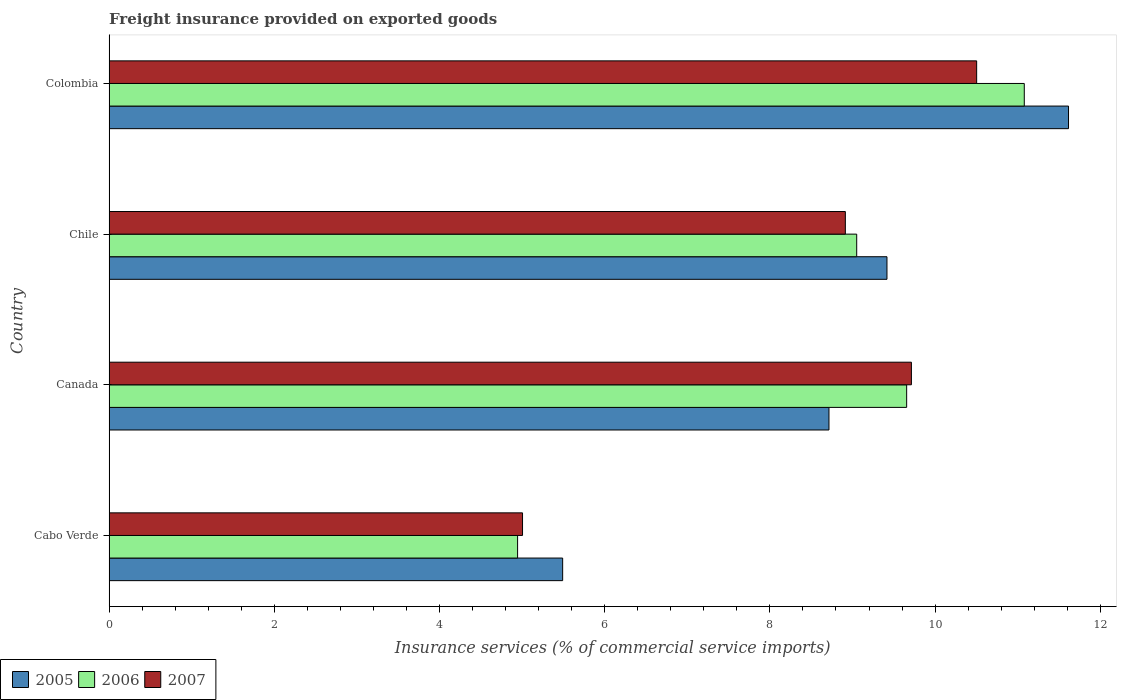How many different coloured bars are there?
Offer a very short reply. 3. Are the number of bars per tick equal to the number of legend labels?
Ensure brevity in your answer.  Yes. Are the number of bars on each tick of the Y-axis equal?
Offer a very short reply. Yes. How many bars are there on the 1st tick from the top?
Offer a very short reply. 3. What is the freight insurance provided on exported goods in 2006 in Cabo Verde?
Make the answer very short. 4.95. Across all countries, what is the maximum freight insurance provided on exported goods in 2006?
Your answer should be very brief. 11.08. Across all countries, what is the minimum freight insurance provided on exported goods in 2005?
Keep it short and to the point. 5.49. In which country was the freight insurance provided on exported goods in 2006 minimum?
Your answer should be compact. Cabo Verde. What is the total freight insurance provided on exported goods in 2005 in the graph?
Provide a succinct answer. 35.24. What is the difference between the freight insurance provided on exported goods in 2007 in Canada and that in Chile?
Your response must be concise. 0.8. What is the difference between the freight insurance provided on exported goods in 2005 in Canada and the freight insurance provided on exported goods in 2006 in Chile?
Ensure brevity in your answer.  -0.34. What is the average freight insurance provided on exported goods in 2005 per country?
Keep it short and to the point. 8.81. What is the difference between the freight insurance provided on exported goods in 2007 and freight insurance provided on exported goods in 2005 in Canada?
Offer a terse response. 1. What is the ratio of the freight insurance provided on exported goods in 2006 in Cabo Verde to that in Canada?
Offer a very short reply. 0.51. Is the freight insurance provided on exported goods in 2006 in Canada less than that in Colombia?
Your answer should be compact. Yes. What is the difference between the highest and the second highest freight insurance provided on exported goods in 2006?
Provide a short and direct response. 1.42. What is the difference between the highest and the lowest freight insurance provided on exported goods in 2005?
Your answer should be compact. 6.12. Is the sum of the freight insurance provided on exported goods in 2006 in Cabo Verde and Colombia greater than the maximum freight insurance provided on exported goods in 2007 across all countries?
Keep it short and to the point. Yes. What does the 1st bar from the top in Chile represents?
Provide a short and direct response. 2007. What does the 3rd bar from the bottom in Canada represents?
Make the answer very short. 2007. Is it the case that in every country, the sum of the freight insurance provided on exported goods in 2007 and freight insurance provided on exported goods in 2005 is greater than the freight insurance provided on exported goods in 2006?
Your response must be concise. Yes. Are the values on the major ticks of X-axis written in scientific E-notation?
Make the answer very short. No. Does the graph contain any zero values?
Give a very brief answer. No. Does the graph contain grids?
Your response must be concise. No. Where does the legend appear in the graph?
Provide a succinct answer. Bottom left. How many legend labels are there?
Ensure brevity in your answer.  3. How are the legend labels stacked?
Provide a succinct answer. Horizontal. What is the title of the graph?
Provide a short and direct response. Freight insurance provided on exported goods. Does "2015" appear as one of the legend labels in the graph?
Provide a short and direct response. No. What is the label or title of the X-axis?
Provide a short and direct response. Insurance services (% of commercial service imports). What is the Insurance services (% of commercial service imports) in 2005 in Cabo Verde?
Your answer should be very brief. 5.49. What is the Insurance services (% of commercial service imports) in 2006 in Cabo Verde?
Your response must be concise. 4.95. What is the Insurance services (% of commercial service imports) in 2007 in Cabo Verde?
Provide a short and direct response. 5.01. What is the Insurance services (% of commercial service imports) of 2005 in Canada?
Provide a short and direct response. 8.72. What is the Insurance services (% of commercial service imports) of 2006 in Canada?
Ensure brevity in your answer.  9.66. What is the Insurance services (% of commercial service imports) of 2007 in Canada?
Keep it short and to the point. 9.71. What is the Insurance services (% of commercial service imports) in 2005 in Chile?
Your answer should be compact. 9.42. What is the Insurance services (% of commercial service imports) of 2006 in Chile?
Your answer should be very brief. 9.05. What is the Insurance services (% of commercial service imports) of 2007 in Chile?
Provide a succinct answer. 8.91. What is the Insurance services (% of commercial service imports) in 2005 in Colombia?
Ensure brevity in your answer.  11.62. What is the Insurance services (% of commercial service imports) in 2006 in Colombia?
Provide a succinct answer. 11.08. What is the Insurance services (% of commercial service imports) in 2007 in Colombia?
Your answer should be compact. 10.5. Across all countries, what is the maximum Insurance services (% of commercial service imports) in 2005?
Give a very brief answer. 11.62. Across all countries, what is the maximum Insurance services (% of commercial service imports) of 2006?
Provide a succinct answer. 11.08. Across all countries, what is the maximum Insurance services (% of commercial service imports) in 2007?
Keep it short and to the point. 10.5. Across all countries, what is the minimum Insurance services (% of commercial service imports) in 2005?
Your answer should be very brief. 5.49. Across all countries, what is the minimum Insurance services (% of commercial service imports) in 2006?
Ensure brevity in your answer.  4.95. Across all countries, what is the minimum Insurance services (% of commercial service imports) of 2007?
Your answer should be compact. 5.01. What is the total Insurance services (% of commercial service imports) of 2005 in the graph?
Give a very brief answer. 35.24. What is the total Insurance services (% of commercial service imports) of 2006 in the graph?
Your response must be concise. 34.73. What is the total Insurance services (% of commercial service imports) in 2007 in the graph?
Provide a succinct answer. 34.14. What is the difference between the Insurance services (% of commercial service imports) of 2005 in Cabo Verde and that in Canada?
Offer a very short reply. -3.22. What is the difference between the Insurance services (% of commercial service imports) of 2006 in Cabo Verde and that in Canada?
Your answer should be very brief. -4.71. What is the difference between the Insurance services (% of commercial service imports) in 2007 in Cabo Verde and that in Canada?
Provide a succinct answer. -4.71. What is the difference between the Insurance services (% of commercial service imports) of 2005 in Cabo Verde and that in Chile?
Provide a succinct answer. -3.93. What is the difference between the Insurance services (% of commercial service imports) of 2006 in Cabo Verde and that in Chile?
Provide a short and direct response. -4.11. What is the difference between the Insurance services (% of commercial service imports) in 2007 in Cabo Verde and that in Chile?
Ensure brevity in your answer.  -3.91. What is the difference between the Insurance services (% of commercial service imports) of 2005 in Cabo Verde and that in Colombia?
Give a very brief answer. -6.12. What is the difference between the Insurance services (% of commercial service imports) in 2006 in Cabo Verde and that in Colombia?
Provide a succinct answer. -6.13. What is the difference between the Insurance services (% of commercial service imports) in 2007 in Cabo Verde and that in Colombia?
Your response must be concise. -5.5. What is the difference between the Insurance services (% of commercial service imports) of 2005 in Canada and that in Chile?
Offer a terse response. -0.7. What is the difference between the Insurance services (% of commercial service imports) of 2006 in Canada and that in Chile?
Provide a short and direct response. 0.6. What is the difference between the Insurance services (% of commercial service imports) of 2007 in Canada and that in Chile?
Provide a short and direct response. 0.8. What is the difference between the Insurance services (% of commercial service imports) of 2005 in Canada and that in Colombia?
Keep it short and to the point. -2.9. What is the difference between the Insurance services (% of commercial service imports) in 2006 in Canada and that in Colombia?
Your answer should be very brief. -1.42. What is the difference between the Insurance services (% of commercial service imports) of 2007 in Canada and that in Colombia?
Give a very brief answer. -0.79. What is the difference between the Insurance services (% of commercial service imports) of 2005 in Chile and that in Colombia?
Offer a terse response. -2.2. What is the difference between the Insurance services (% of commercial service imports) of 2006 in Chile and that in Colombia?
Your answer should be very brief. -2.03. What is the difference between the Insurance services (% of commercial service imports) in 2007 in Chile and that in Colombia?
Give a very brief answer. -1.59. What is the difference between the Insurance services (% of commercial service imports) of 2005 in Cabo Verde and the Insurance services (% of commercial service imports) of 2006 in Canada?
Your answer should be compact. -4.16. What is the difference between the Insurance services (% of commercial service imports) in 2005 in Cabo Verde and the Insurance services (% of commercial service imports) in 2007 in Canada?
Offer a very short reply. -4.22. What is the difference between the Insurance services (% of commercial service imports) of 2006 in Cabo Verde and the Insurance services (% of commercial service imports) of 2007 in Canada?
Provide a short and direct response. -4.77. What is the difference between the Insurance services (% of commercial service imports) of 2005 in Cabo Verde and the Insurance services (% of commercial service imports) of 2006 in Chile?
Provide a short and direct response. -3.56. What is the difference between the Insurance services (% of commercial service imports) in 2005 in Cabo Verde and the Insurance services (% of commercial service imports) in 2007 in Chile?
Provide a succinct answer. -3.42. What is the difference between the Insurance services (% of commercial service imports) of 2006 in Cabo Verde and the Insurance services (% of commercial service imports) of 2007 in Chile?
Your response must be concise. -3.97. What is the difference between the Insurance services (% of commercial service imports) in 2005 in Cabo Verde and the Insurance services (% of commercial service imports) in 2006 in Colombia?
Offer a very short reply. -5.59. What is the difference between the Insurance services (% of commercial service imports) of 2005 in Cabo Verde and the Insurance services (% of commercial service imports) of 2007 in Colombia?
Give a very brief answer. -5.01. What is the difference between the Insurance services (% of commercial service imports) in 2006 in Cabo Verde and the Insurance services (% of commercial service imports) in 2007 in Colombia?
Your answer should be compact. -5.56. What is the difference between the Insurance services (% of commercial service imports) of 2005 in Canada and the Insurance services (% of commercial service imports) of 2006 in Chile?
Your answer should be very brief. -0.34. What is the difference between the Insurance services (% of commercial service imports) in 2005 in Canada and the Insurance services (% of commercial service imports) in 2007 in Chile?
Make the answer very short. -0.2. What is the difference between the Insurance services (% of commercial service imports) in 2006 in Canada and the Insurance services (% of commercial service imports) in 2007 in Chile?
Offer a terse response. 0.74. What is the difference between the Insurance services (% of commercial service imports) of 2005 in Canada and the Insurance services (% of commercial service imports) of 2006 in Colombia?
Ensure brevity in your answer.  -2.36. What is the difference between the Insurance services (% of commercial service imports) of 2005 in Canada and the Insurance services (% of commercial service imports) of 2007 in Colombia?
Provide a succinct answer. -1.79. What is the difference between the Insurance services (% of commercial service imports) of 2006 in Canada and the Insurance services (% of commercial service imports) of 2007 in Colombia?
Offer a very short reply. -0.85. What is the difference between the Insurance services (% of commercial service imports) in 2005 in Chile and the Insurance services (% of commercial service imports) in 2006 in Colombia?
Ensure brevity in your answer.  -1.66. What is the difference between the Insurance services (% of commercial service imports) of 2005 in Chile and the Insurance services (% of commercial service imports) of 2007 in Colombia?
Make the answer very short. -1.09. What is the difference between the Insurance services (% of commercial service imports) of 2006 in Chile and the Insurance services (% of commercial service imports) of 2007 in Colombia?
Your answer should be very brief. -1.45. What is the average Insurance services (% of commercial service imports) of 2005 per country?
Your answer should be compact. 8.81. What is the average Insurance services (% of commercial service imports) in 2006 per country?
Offer a terse response. 8.68. What is the average Insurance services (% of commercial service imports) in 2007 per country?
Keep it short and to the point. 8.53. What is the difference between the Insurance services (% of commercial service imports) in 2005 and Insurance services (% of commercial service imports) in 2006 in Cabo Verde?
Give a very brief answer. 0.55. What is the difference between the Insurance services (% of commercial service imports) in 2005 and Insurance services (% of commercial service imports) in 2007 in Cabo Verde?
Keep it short and to the point. 0.49. What is the difference between the Insurance services (% of commercial service imports) of 2006 and Insurance services (% of commercial service imports) of 2007 in Cabo Verde?
Your response must be concise. -0.06. What is the difference between the Insurance services (% of commercial service imports) in 2005 and Insurance services (% of commercial service imports) in 2006 in Canada?
Offer a terse response. -0.94. What is the difference between the Insurance services (% of commercial service imports) in 2005 and Insurance services (% of commercial service imports) in 2007 in Canada?
Provide a succinct answer. -1. What is the difference between the Insurance services (% of commercial service imports) in 2006 and Insurance services (% of commercial service imports) in 2007 in Canada?
Give a very brief answer. -0.06. What is the difference between the Insurance services (% of commercial service imports) in 2005 and Insurance services (% of commercial service imports) in 2006 in Chile?
Give a very brief answer. 0.37. What is the difference between the Insurance services (% of commercial service imports) in 2005 and Insurance services (% of commercial service imports) in 2007 in Chile?
Your response must be concise. 0.5. What is the difference between the Insurance services (% of commercial service imports) of 2006 and Insurance services (% of commercial service imports) of 2007 in Chile?
Provide a succinct answer. 0.14. What is the difference between the Insurance services (% of commercial service imports) of 2005 and Insurance services (% of commercial service imports) of 2006 in Colombia?
Offer a terse response. 0.54. What is the difference between the Insurance services (% of commercial service imports) of 2005 and Insurance services (% of commercial service imports) of 2007 in Colombia?
Your answer should be compact. 1.11. What is the difference between the Insurance services (% of commercial service imports) of 2006 and Insurance services (% of commercial service imports) of 2007 in Colombia?
Ensure brevity in your answer.  0.58. What is the ratio of the Insurance services (% of commercial service imports) of 2005 in Cabo Verde to that in Canada?
Offer a very short reply. 0.63. What is the ratio of the Insurance services (% of commercial service imports) of 2006 in Cabo Verde to that in Canada?
Keep it short and to the point. 0.51. What is the ratio of the Insurance services (% of commercial service imports) of 2007 in Cabo Verde to that in Canada?
Give a very brief answer. 0.52. What is the ratio of the Insurance services (% of commercial service imports) in 2005 in Cabo Verde to that in Chile?
Provide a succinct answer. 0.58. What is the ratio of the Insurance services (% of commercial service imports) of 2006 in Cabo Verde to that in Chile?
Offer a terse response. 0.55. What is the ratio of the Insurance services (% of commercial service imports) of 2007 in Cabo Verde to that in Chile?
Ensure brevity in your answer.  0.56. What is the ratio of the Insurance services (% of commercial service imports) of 2005 in Cabo Verde to that in Colombia?
Provide a short and direct response. 0.47. What is the ratio of the Insurance services (% of commercial service imports) of 2006 in Cabo Verde to that in Colombia?
Keep it short and to the point. 0.45. What is the ratio of the Insurance services (% of commercial service imports) in 2007 in Cabo Verde to that in Colombia?
Your response must be concise. 0.48. What is the ratio of the Insurance services (% of commercial service imports) in 2005 in Canada to that in Chile?
Provide a succinct answer. 0.93. What is the ratio of the Insurance services (% of commercial service imports) in 2006 in Canada to that in Chile?
Offer a very short reply. 1.07. What is the ratio of the Insurance services (% of commercial service imports) in 2007 in Canada to that in Chile?
Offer a terse response. 1.09. What is the ratio of the Insurance services (% of commercial service imports) of 2005 in Canada to that in Colombia?
Make the answer very short. 0.75. What is the ratio of the Insurance services (% of commercial service imports) of 2006 in Canada to that in Colombia?
Offer a terse response. 0.87. What is the ratio of the Insurance services (% of commercial service imports) in 2007 in Canada to that in Colombia?
Keep it short and to the point. 0.92. What is the ratio of the Insurance services (% of commercial service imports) of 2005 in Chile to that in Colombia?
Offer a very short reply. 0.81. What is the ratio of the Insurance services (% of commercial service imports) of 2006 in Chile to that in Colombia?
Your answer should be very brief. 0.82. What is the ratio of the Insurance services (% of commercial service imports) of 2007 in Chile to that in Colombia?
Offer a very short reply. 0.85. What is the difference between the highest and the second highest Insurance services (% of commercial service imports) in 2005?
Ensure brevity in your answer.  2.2. What is the difference between the highest and the second highest Insurance services (% of commercial service imports) of 2006?
Your response must be concise. 1.42. What is the difference between the highest and the second highest Insurance services (% of commercial service imports) in 2007?
Make the answer very short. 0.79. What is the difference between the highest and the lowest Insurance services (% of commercial service imports) in 2005?
Give a very brief answer. 6.12. What is the difference between the highest and the lowest Insurance services (% of commercial service imports) in 2006?
Your answer should be compact. 6.13. What is the difference between the highest and the lowest Insurance services (% of commercial service imports) of 2007?
Provide a succinct answer. 5.5. 